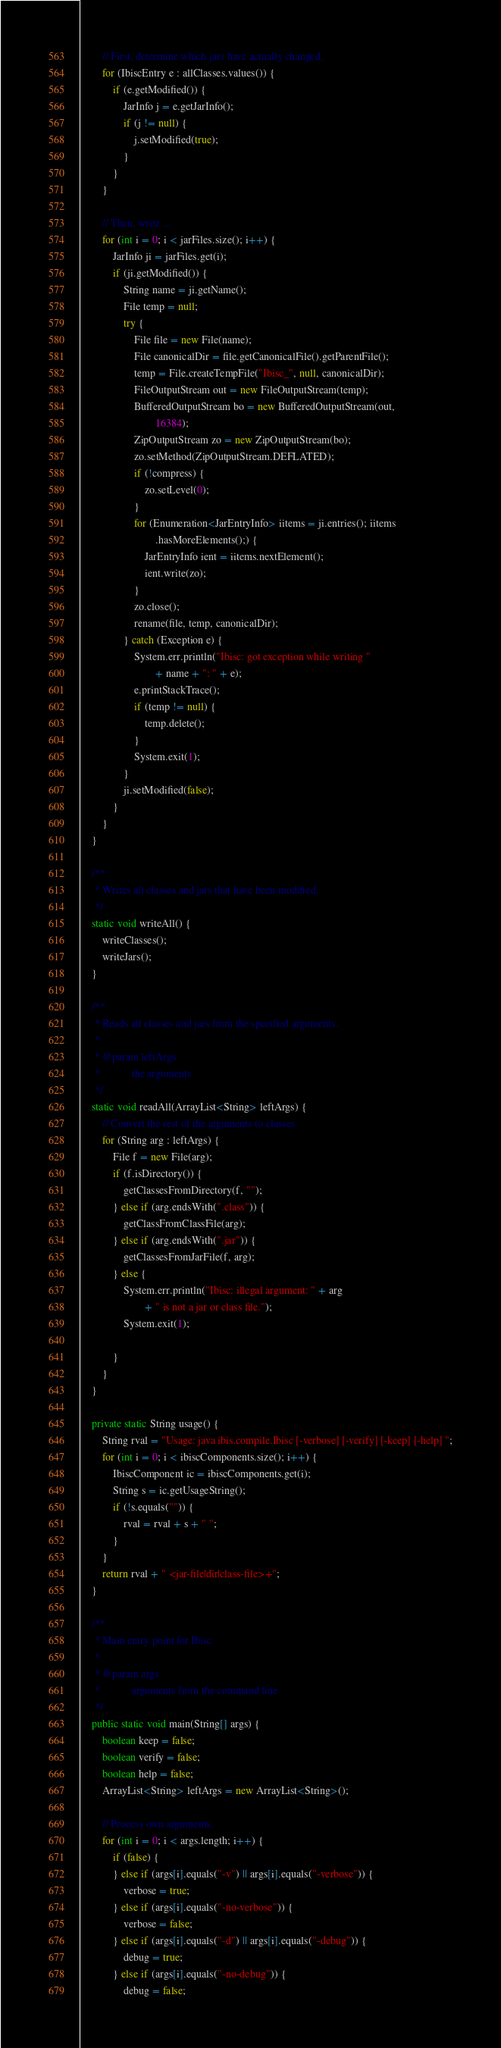<code> <loc_0><loc_0><loc_500><loc_500><_Java_>        // First, determine which jars have actually changed.
        for (IbiscEntry e : allClasses.values()) {
            if (e.getModified()) {
                JarInfo j = e.getJarInfo();
                if (j != null) {
                    j.setModified(true);
                }
            }
        }

        // Then, write ...
        for (int i = 0; i < jarFiles.size(); i++) {
            JarInfo ji = jarFiles.get(i);
            if (ji.getModified()) {
                String name = ji.getName();
                File temp = null;
                try {
                    File file = new File(name);
                    File canonicalDir = file.getCanonicalFile().getParentFile();
                    temp = File.createTempFile("Ibisc_", null, canonicalDir);
                    FileOutputStream out = new FileOutputStream(temp);
                    BufferedOutputStream bo = new BufferedOutputStream(out,
                            16384);
                    ZipOutputStream zo = new ZipOutputStream(bo);
                    zo.setMethod(ZipOutputStream.DEFLATED);
                    if (!compress) {
                        zo.setLevel(0);
                    }
                    for (Enumeration<JarEntryInfo> iitems = ji.entries(); iitems
                            .hasMoreElements();) {
                        JarEntryInfo ient = iitems.nextElement();
                        ient.write(zo);
                    }
                    zo.close();
                    rename(file, temp, canonicalDir);
                } catch (Exception e) {
                    System.err.println("Ibisc: got exception while writing "
                            + name + ": " + e);
                    e.printStackTrace();
                    if (temp != null) {
                        temp.delete();
                    }
                    System.exit(1);
                }
                ji.setModified(false);
            }
        }
    }

    /**
     * Writes all classes and jars that have been modified.
     */
    static void writeAll() {
        writeClasses();
        writeJars();
    }

    /**
     * Reads all classes and jars from the specified arguments.
     * 
     * @param leftArgs
     *            the arguments.
     */
    static void readAll(ArrayList<String> leftArgs) {
        // Convert the rest of the arguments to classes
        for (String arg : leftArgs) {
            File f = new File(arg);
            if (f.isDirectory()) {
                getClassesFromDirectory(f, "");
            } else if (arg.endsWith(".class")) {
                getClassFromClassFile(arg);
            } else if (arg.endsWith(".jar")) {
                getClassesFromJarFile(f, arg);
            } else {
                System.err.println("Ibisc: illegal argument: " + arg
                        + " is not a jar or class file.");
                System.exit(1);

            }
        }
    }

    private static String usage() {
        String rval = "Usage: java ibis.compile.Ibisc [-verbose] [-verify] [-keep] [-help] ";
        for (int i = 0; i < ibiscComponents.size(); i++) {
            IbiscComponent ic = ibiscComponents.get(i);
            String s = ic.getUsageString();
            if (!s.equals("")) {
                rval = rval + s + " ";
            }
        }
        return rval + " <jar-file|dir|class-file>+";
    }

    /**
     * Main entry point for Ibisc
     * 
     * @param args
     *            arguments from the command line
     */
    public static void main(String[] args) {
        boolean keep = false;
        boolean verify = false;
        boolean help = false;
        ArrayList<String> leftArgs = new ArrayList<String>();

        // Process own arguments.
        for (int i = 0; i < args.length; i++) {
            if (false) {
            } else if (args[i].equals("-v") || args[i].equals("-verbose")) {
                verbose = true;
            } else if (args[i].equals("-no-verbose")) {
                verbose = false;
            } else if (args[i].equals("-d") || args[i].equals("-debug")) {
                debug = true;
            } else if (args[i].equals("-no-debug")) {
                debug = false;</code> 